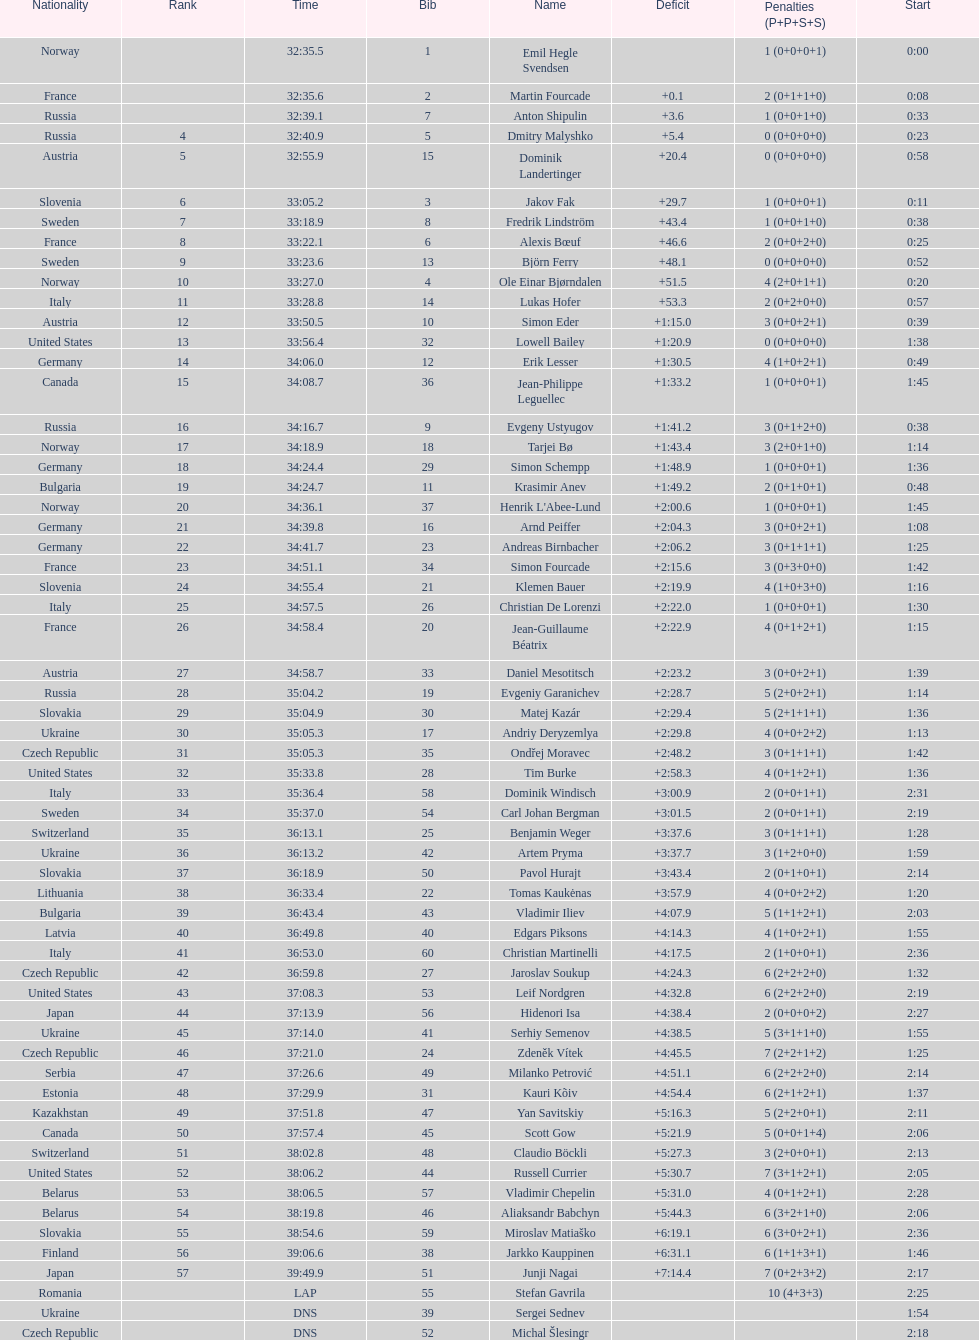How many took at least 35:00 to finish? 30. 